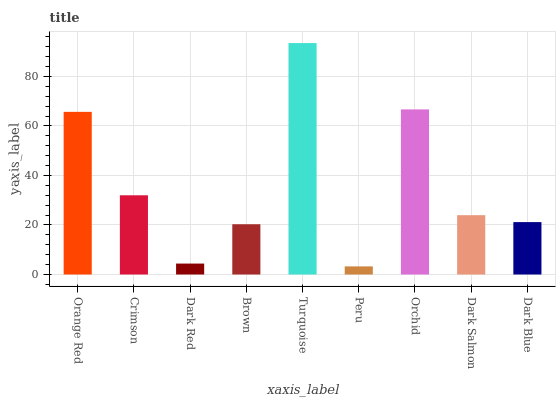Is Peru the minimum?
Answer yes or no. Yes. Is Turquoise the maximum?
Answer yes or no. Yes. Is Crimson the minimum?
Answer yes or no. No. Is Crimson the maximum?
Answer yes or no. No. Is Orange Red greater than Crimson?
Answer yes or no. Yes. Is Crimson less than Orange Red?
Answer yes or no. Yes. Is Crimson greater than Orange Red?
Answer yes or no. No. Is Orange Red less than Crimson?
Answer yes or no. No. Is Dark Salmon the high median?
Answer yes or no. Yes. Is Dark Salmon the low median?
Answer yes or no. Yes. Is Dark Red the high median?
Answer yes or no. No. Is Turquoise the low median?
Answer yes or no. No. 